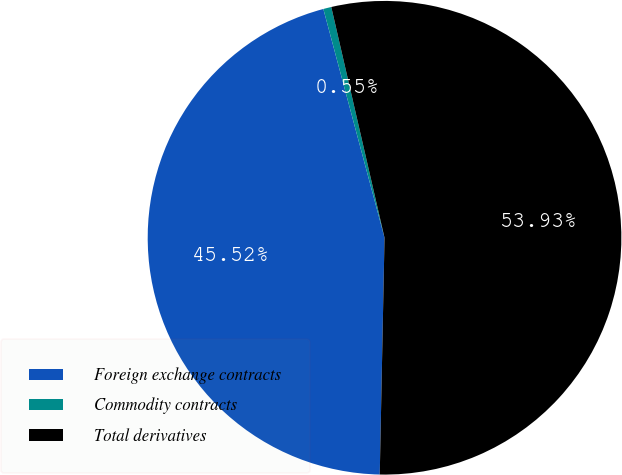Convert chart. <chart><loc_0><loc_0><loc_500><loc_500><pie_chart><fcel>Foreign exchange contracts<fcel>Commodity contracts<fcel>Total derivatives<nl><fcel>45.52%<fcel>0.55%<fcel>53.93%<nl></chart> 